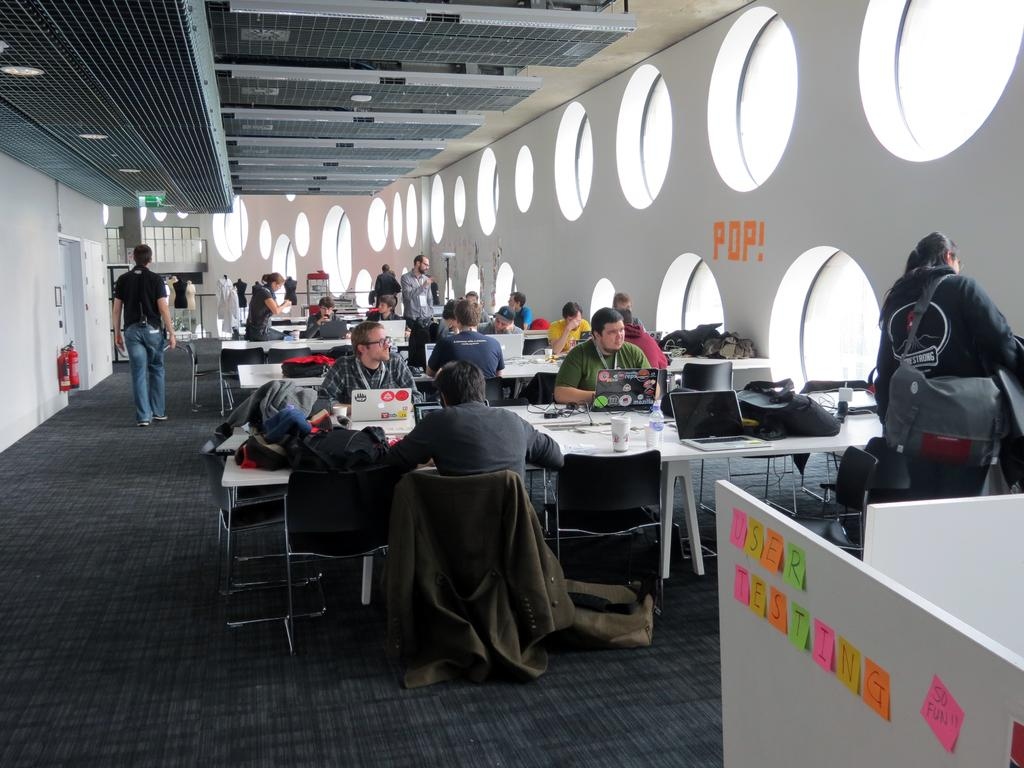<image>
Summarize the visual content of the image. partition with post it notes message user testing so fun!! with tables full of people and wall with round windows 